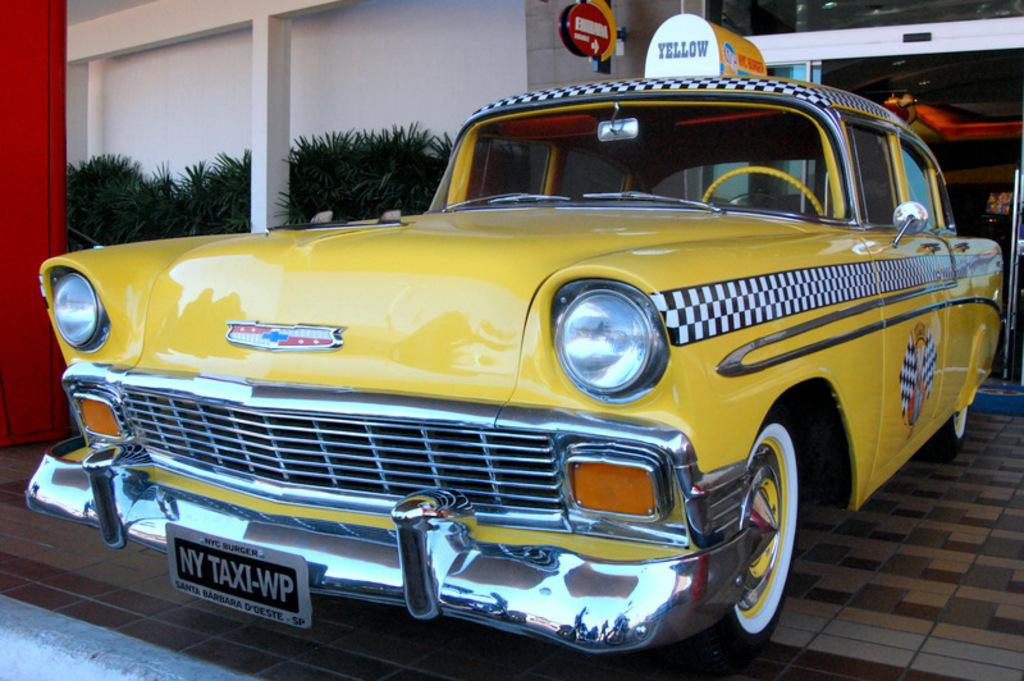<image>
Write a terse but informative summary of the picture. a taxi that has the word yellow at the top 